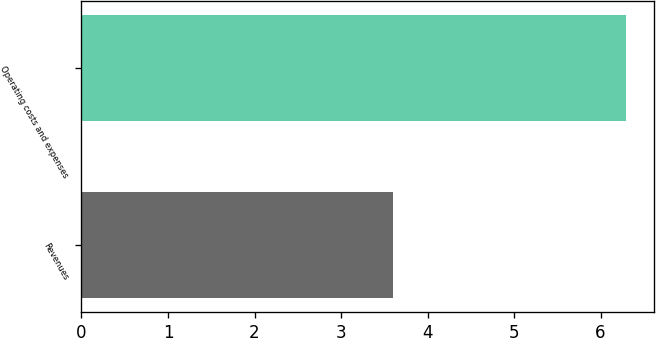<chart> <loc_0><loc_0><loc_500><loc_500><bar_chart><fcel>Revenues<fcel>Operating costs and expenses<nl><fcel>3.6<fcel>6.3<nl></chart> 